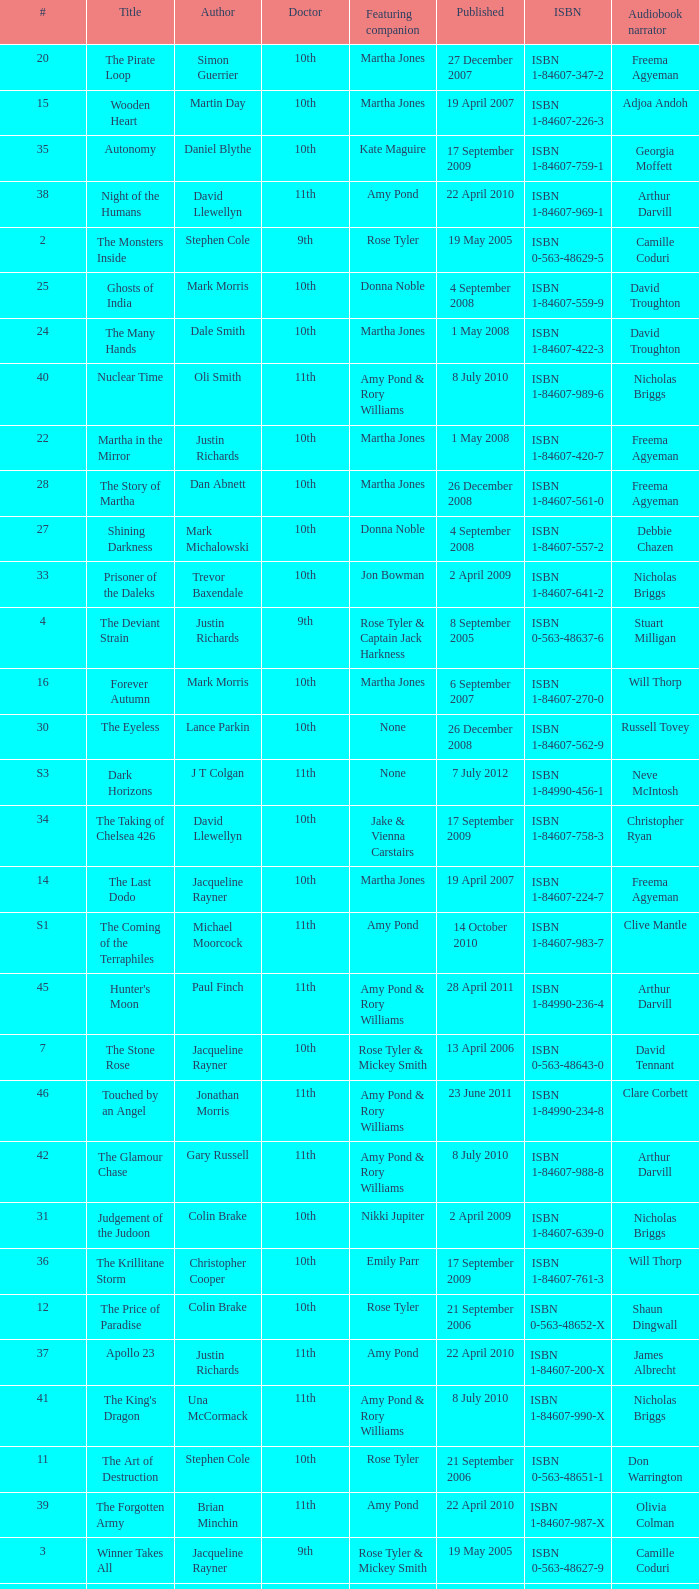Who are the featuring companions of number 3? Rose Tyler & Mickey Smith. 